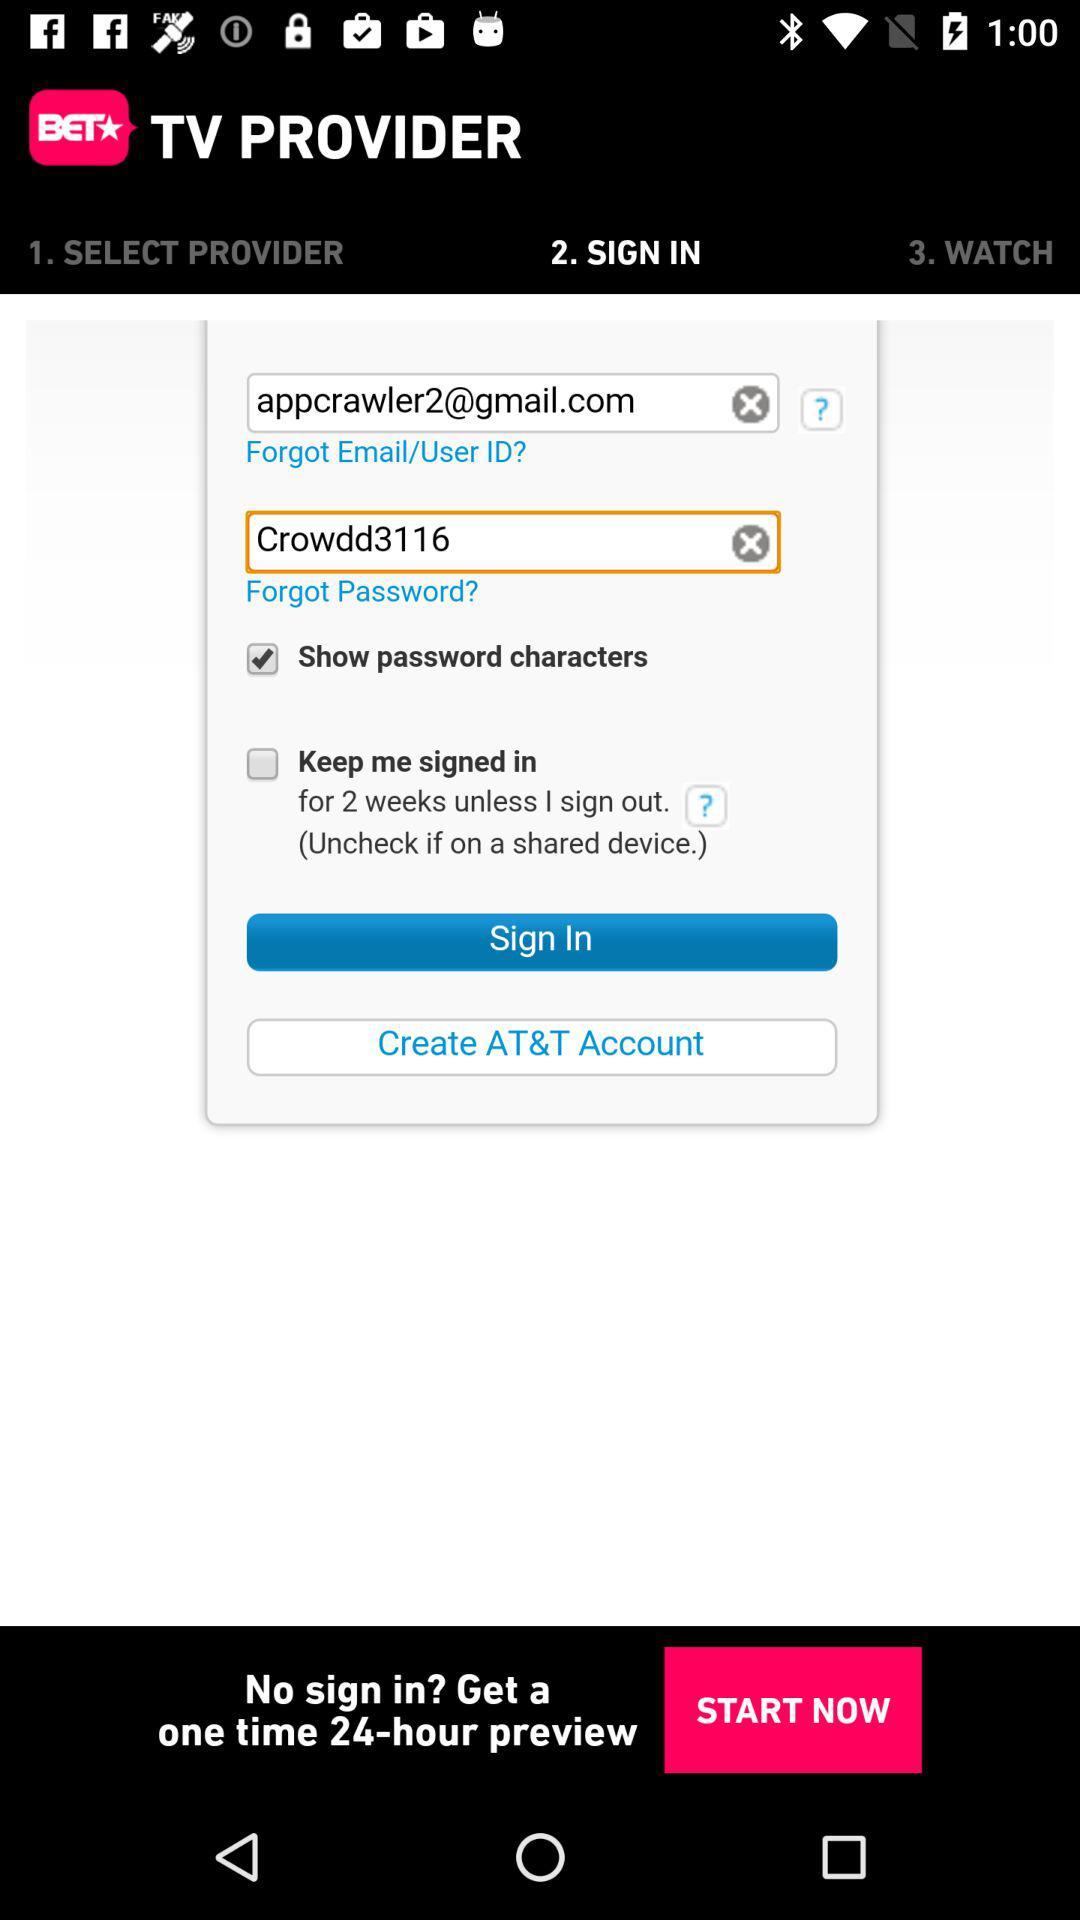Which tab is selected? The selected tab is "SIGN IN". 